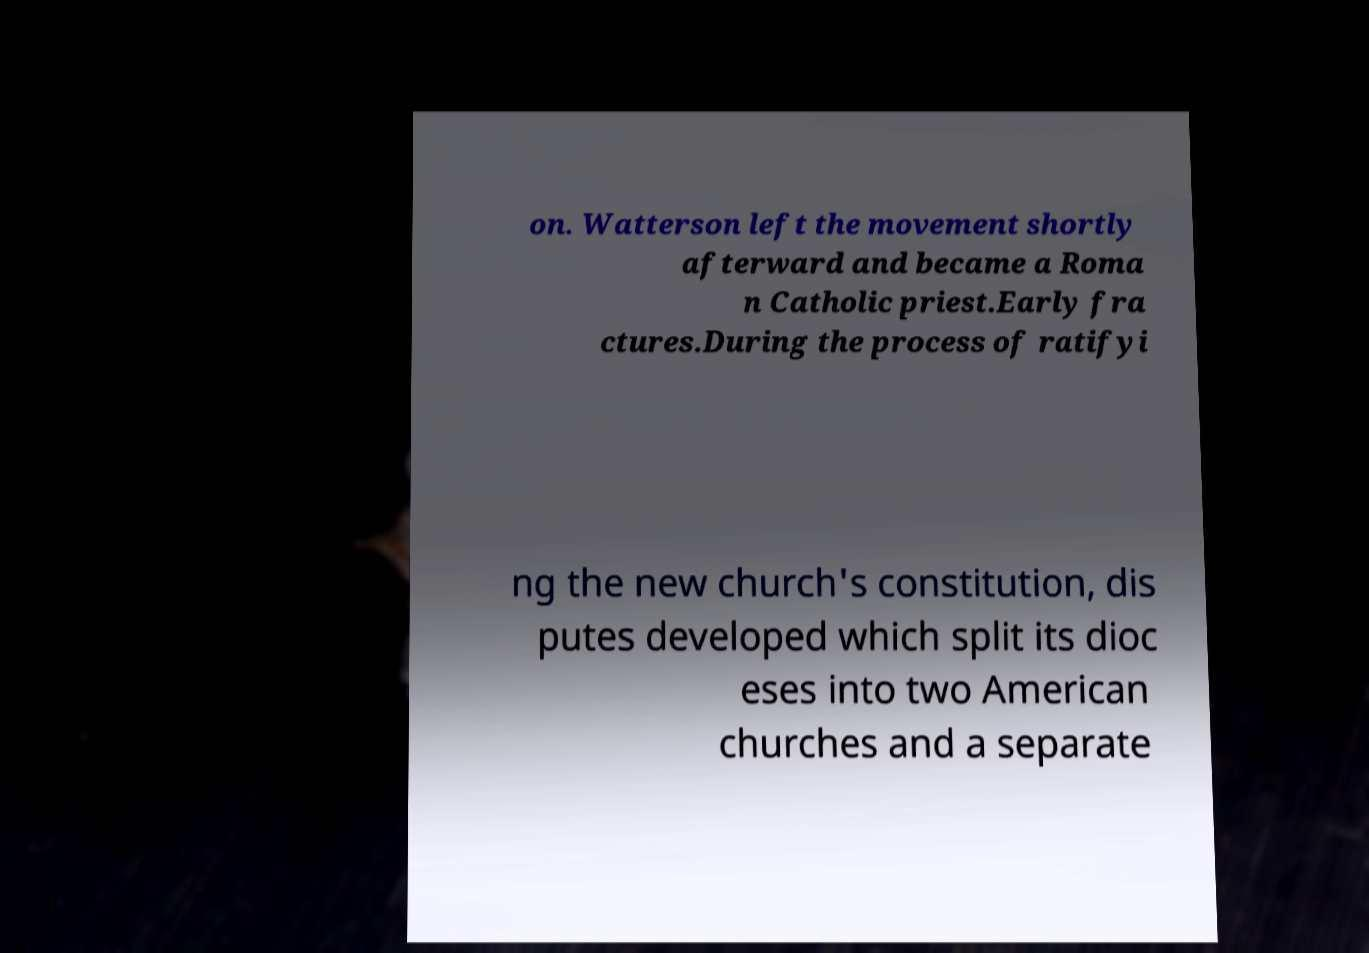Please read and relay the text visible in this image. What does it say? on. Watterson left the movement shortly afterward and became a Roma n Catholic priest.Early fra ctures.During the process of ratifyi ng the new church's constitution, dis putes developed which split its dioc eses into two American churches and a separate 